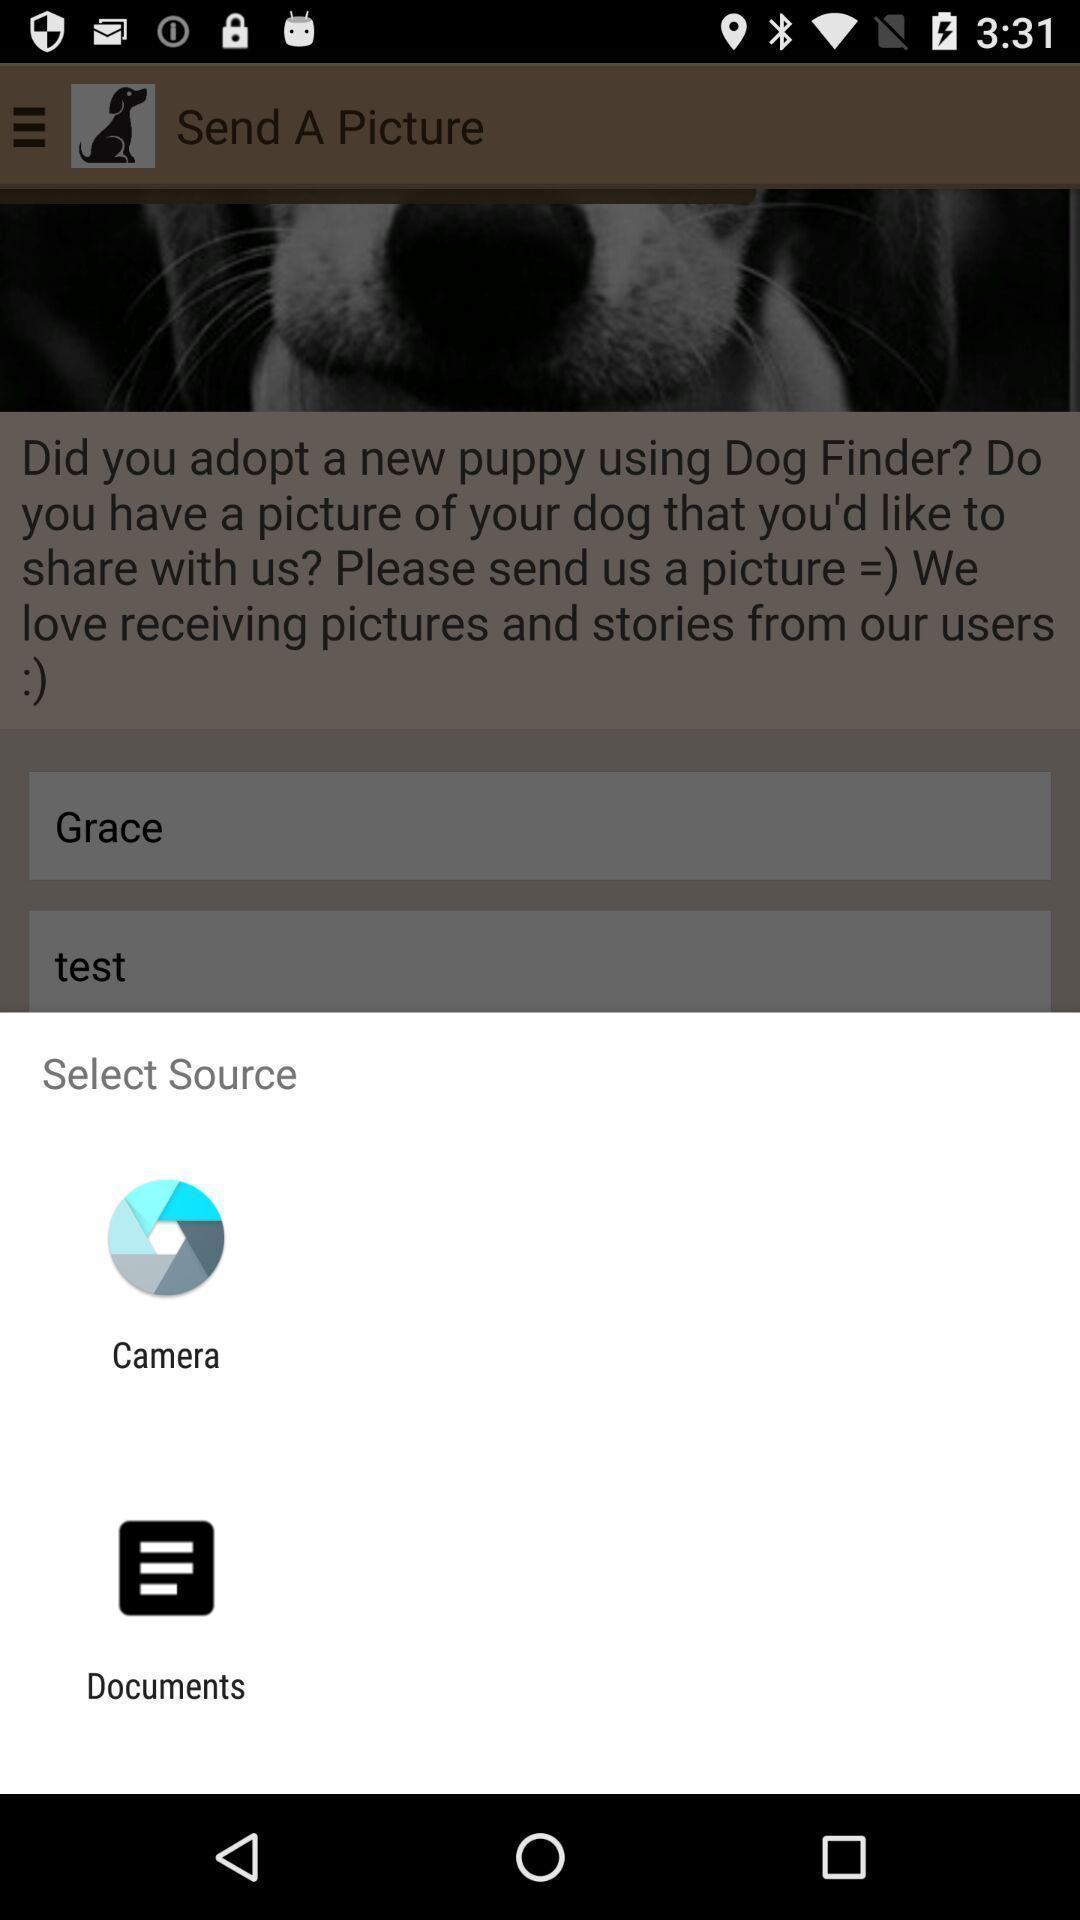Describe the visual elements of this screenshot. Pop-up showing applications to select. 